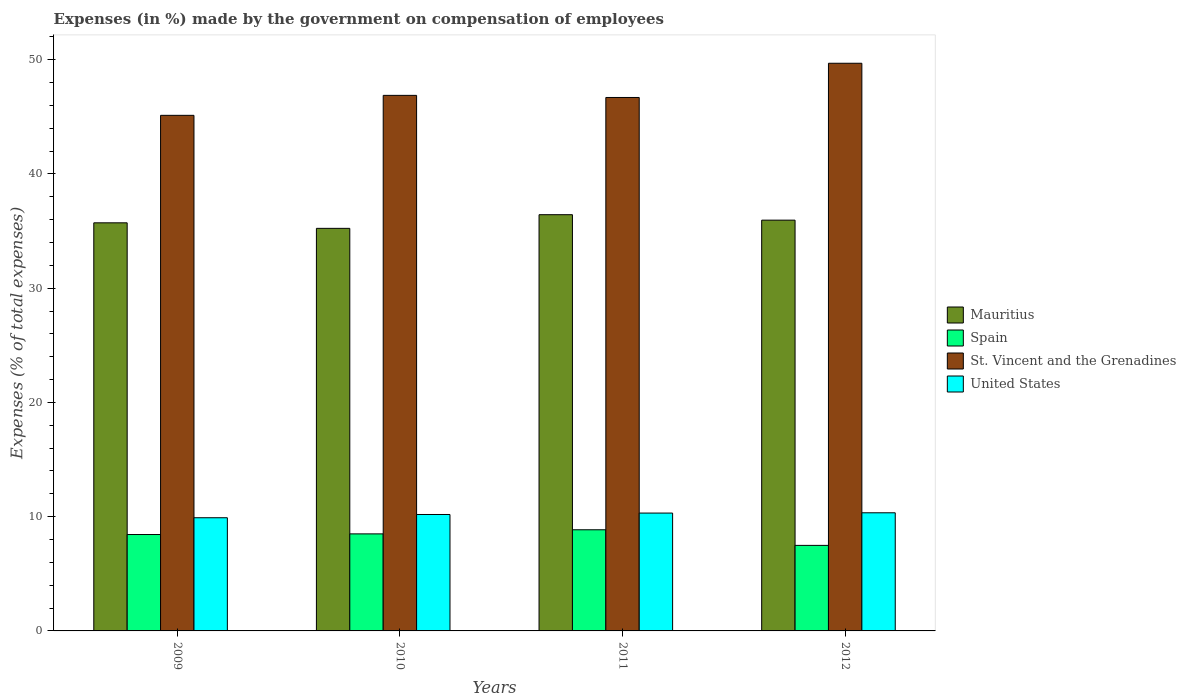Are the number of bars on each tick of the X-axis equal?
Your answer should be very brief. Yes. How many bars are there on the 2nd tick from the left?
Offer a very short reply. 4. How many bars are there on the 2nd tick from the right?
Your response must be concise. 4. What is the label of the 2nd group of bars from the left?
Keep it short and to the point. 2010. What is the percentage of expenses made by the government on compensation of employees in United States in 2011?
Make the answer very short. 10.31. Across all years, what is the maximum percentage of expenses made by the government on compensation of employees in United States?
Keep it short and to the point. 10.34. Across all years, what is the minimum percentage of expenses made by the government on compensation of employees in Spain?
Provide a succinct answer. 7.49. In which year was the percentage of expenses made by the government on compensation of employees in Mauritius maximum?
Your response must be concise. 2011. What is the total percentage of expenses made by the government on compensation of employees in St. Vincent and the Grenadines in the graph?
Your answer should be compact. 188.37. What is the difference between the percentage of expenses made by the government on compensation of employees in United States in 2011 and that in 2012?
Offer a terse response. -0.02. What is the difference between the percentage of expenses made by the government on compensation of employees in St. Vincent and the Grenadines in 2011 and the percentage of expenses made by the government on compensation of employees in Spain in 2010?
Make the answer very short. 38.2. What is the average percentage of expenses made by the government on compensation of employees in Spain per year?
Your answer should be very brief. 8.32. In the year 2011, what is the difference between the percentage of expenses made by the government on compensation of employees in Spain and percentage of expenses made by the government on compensation of employees in United States?
Offer a terse response. -1.46. In how many years, is the percentage of expenses made by the government on compensation of employees in St. Vincent and the Grenadines greater than 44 %?
Your response must be concise. 4. What is the ratio of the percentage of expenses made by the government on compensation of employees in Spain in 2009 to that in 2010?
Keep it short and to the point. 0.99. Is the percentage of expenses made by the government on compensation of employees in United States in 2010 less than that in 2012?
Offer a terse response. Yes. Is the difference between the percentage of expenses made by the government on compensation of employees in Spain in 2010 and 2011 greater than the difference between the percentage of expenses made by the government on compensation of employees in United States in 2010 and 2011?
Your response must be concise. No. What is the difference between the highest and the second highest percentage of expenses made by the government on compensation of employees in Mauritius?
Offer a terse response. 0.48. What is the difference between the highest and the lowest percentage of expenses made by the government on compensation of employees in Spain?
Your answer should be very brief. 1.37. In how many years, is the percentage of expenses made by the government on compensation of employees in United States greater than the average percentage of expenses made by the government on compensation of employees in United States taken over all years?
Ensure brevity in your answer.  3. Is the sum of the percentage of expenses made by the government on compensation of employees in United States in 2009 and 2010 greater than the maximum percentage of expenses made by the government on compensation of employees in Spain across all years?
Give a very brief answer. Yes. What does the 1st bar from the left in 2009 represents?
Provide a short and direct response. Mauritius. What does the 4th bar from the right in 2012 represents?
Keep it short and to the point. Mauritius. Are all the bars in the graph horizontal?
Provide a succinct answer. No. How many years are there in the graph?
Keep it short and to the point. 4. What is the difference between two consecutive major ticks on the Y-axis?
Provide a succinct answer. 10. Are the values on the major ticks of Y-axis written in scientific E-notation?
Offer a terse response. No. Does the graph contain grids?
Make the answer very short. No. How are the legend labels stacked?
Your answer should be very brief. Vertical. What is the title of the graph?
Your answer should be very brief. Expenses (in %) made by the government on compensation of employees. Does "Italy" appear as one of the legend labels in the graph?
Your answer should be compact. No. What is the label or title of the Y-axis?
Ensure brevity in your answer.  Expenses (% of total expenses). What is the Expenses (% of total expenses) in Mauritius in 2009?
Ensure brevity in your answer.  35.72. What is the Expenses (% of total expenses) in Spain in 2009?
Offer a very short reply. 8.44. What is the Expenses (% of total expenses) of St. Vincent and the Grenadines in 2009?
Keep it short and to the point. 45.13. What is the Expenses (% of total expenses) of United States in 2009?
Your answer should be very brief. 9.91. What is the Expenses (% of total expenses) in Mauritius in 2010?
Ensure brevity in your answer.  35.23. What is the Expenses (% of total expenses) of Spain in 2010?
Ensure brevity in your answer.  8.49. What is the Expenses (% of total expenses) of St. Vincent and the Grenadines in 2010?
Provide a short and direct response. 46.87. What is the Expenses (% of total expenses) in United States in 2010?
Your response must be concise. 10.19. What is the Expenses (% of total expenses) in Mauritius in 2011?
Provide a short and direct response. 36.43. What is the Expenses (% of total expenses) in Spain in 2011?
Your answer should be compact. 8.85. What is the Expenses (% of total expenses) in St. Vincent and the Grenadines in 2011?
Make the answer very short. 46.69. What is the Expenses (% of total expenses) in United States in 2011?
Make the answer very short. 10.31. What is the Expenses (% of total expenses) in Mauritius in 2012?
Make the answer very short. 35.95. What is the Expenses (% of total expenses) of Spain in 2012?
Give a very brief answer. 7.49. What is the Expenses (% of total expenses) in St. Vincent and the Grenadines in 2012?
Your answer should be compact. 49.68. What is the Expenses (% of total expenses) in United States in 2012?
Offer a very short reply. 10.34. Across all years, what is the maximum Expenses (% of total expenses) in Mauritius?
Offer a very short reply. 36.43. Across all years, what is the maximum Expenses (% of total expenses) of Spain?
Offer a very short reply. 8.85. Across all years, what is the maximum Expenses (% of total expenses) in St. Vincent and the Grenadines?
Make the answer very short. 49.68. Across all years, what is the maximum Expenses (% of total expenses) of United States?
Your answer should be very brief. 10.34. Across all years, what is the minimum Expenses (% of total expenses) of Mauritius?
Provide a short and direct response. 35.23. Across all years, what is the minimum Expenses (% of total expenses) of Spain?
Offer a terse response. 7.49. Across all years, what is the minimum Expenses (% of total expenses) in St. Vincent and the Grenadines?
Your response must be concise. 45.13. Across all years, what is the minimum Expenses (% of total expenses) in United States?
Your answer should be very brief. 9.91. What is the total Expenses (% of total expenses) of Mauritius in the graph?
Offer a terse response. 143.33. What is the total Expenses (% of total expenses) of Spain in the graph?
Give a very brief answer. 33.27. What is the total Expenses (% of total expenses) in St. Vincent and the Grenadines in the graph?
Make the answer very short. 188.37. What is the total Expenses (% of total expenses) in United States in the graph?
Ensure brevity in your answer.  40.75. What is the difference between the Expenses (% of total expenses) in Mauritius in 2009 and that in 2010?
Provide a succinct answer. 0.49. What is the difference between the Expenses (% of total expenses) of Spain in 2009 and that in 2010?
Offer a very short reply. -0.06. What is the difference between the Expenses (% of total expenses) in St. Vincent and the Grenadines in 2009 and that in 2010?
Ensure brevity in your answer.  -1.75. What is the difference between the Expenses (% of total expenses) in United States in 2009 and that in 2010?
Your answer should be compact. -0.28. What is the difference between the Expenses (% of total expenses) of Mauritius in 2009 and that in 2011?
Make the answer very short. -0.71. What is the difference between the Expenses (% of total expenses) in Spain in 2009 and that in 2011?
Offer a terse response. -0.42. What is the difference between the Expenses (% of total expenses) of St. Vincent and the Grenadines in 2009 and that in 2011?
Offer a terse response. -1.56. What is the difference between the Expenses (% of total expenses) in United States in 2009 and that in 2011?
Make the answer very short. -0.41. What is the difference between the Expenses (% of total expenses) in Mauritius in 2009 and that in 2012?
Your answer should be very brief. -0.23. What is the difference between the Expenses (% of total expenses) in Spain in 2009 and that in 2012?
Give a very brief answer. 0.95. What is the difference between the Expenses (% of total expenses) of St. Vincent and the Grenadines in 2009 and that in 2012?
Provide a short and direct response. -4.56. What is the difference between the Expenses (% of total expenses) in United States in 2009 and that in 2012?
Your response must be concise. -0.43. What is the difference between the Expenses (% of total expenses) of Mauritius in 2010 and that in 2011?
Offer a very short reply. -1.2. What is the difference between the Expenses (% of total expenses) in Spain in 2010 and that in 2011?
Provide a succinct answer. -0.36. What is the difference between the Expenses (% of total expenses) of St. Vincent and the Grenadines in 2010 and that in 2011?
Offer a very short reply. 0.18. What is the difference between the Expenses (% of total expenses) in United States in 2010 and that in 2011?
Offer a terse response. -0.12. What is the difference between the Expenses (% of total expenses) of Mauritius in 2010 and that in 2012?
Your answer should be very brief. -0.72. What is the difference between the Expenses (% of total expenses) in Spain in 2010 and that in 2012?
Provide a short and direct response. 1.01. What is the difference between the Expenses (% of total expenses) in St. Vincent and the Grenadines in 2010 and that in 2012?
Ensure brevity in your answer.  -2.81. What is the difference between the Expenses (% of total expenses) in United States in 2010 and that in 2012?
Give a very brief answer. -0.15. What is the difference between the Expenses (% of total expenses) in Mauritius in 2011 and that in 2012?
Your answer should be compact. 0.48. What is the difference between the Expenses (% of total expenses) of Spain in 2011 and that in 2012?
Your response must be concise. 1.37. What is the difference between the Expenses (% of total expenses) of St. Vincent and the Grenadines in 2011 and that in 2012?
Give a very brief answer. -2.99. What is the difference between the Expenses (% of total expenses) of United States in 2011 and that in 2012?
Keep it short and to the point. -0.02. What is the difference between the Expenses (% of total expenses) of Mauritius in 2009 and the Expenses (% of total expenses) of Spain in 2010?
Provide a succinct answer. 27.23. What is the difference between the Expenses (% of total expenses) in Mauritius in 2009 and the Expenses (% of total expenses) in St. Vincent and the Grenadines in 2010?
Offer a terse response. -11.15. What is the difference between the Expenses (% of total expenses) in Mauritius in 2009 and the Expenses (% of total expenses) in United States in 2010?
Keep it short and to the point. 25.53. What is the difference between the Expenses (% of total expenses) in Spain in 2009 and the Expenses (% of total expenses) in St. Vincent and the Grenadines in 2010?
Your answer should be very brief. -38.44. What is the difference between the Expenses (% of total expenses) in Spain in 2009 and the Expenses (% of total expenses) in United States in 2010?
Offer a terse response. -1.75. What is the difference between the Expenses (% of total expenses) in St. Vincent and the Grenadines in 2009 and the Expenses (% of total expenses) in United States in 2010?
Your response must be concise. 34.94. What is the difference between the Expenses (% of total expenses) in Mauritius in 2009 and the Expenses (% of total expenses) in Spain in 2011?
Offer a very short reply. 26.87. What is the difference between the Expenses (% of total expenses) in Mauritius in 2009 and the Expenses (% of total expenses) in St. Vincent and the Grenadines in 2011?
Your answer should be compact. -10.97. What is the difference between the Expenses (% of total expenses) in Mauritius in 2009 and the Expenses (% of total expenses) in United States in 2011?
Your answer should be compact. 25.4. What is the difference between the Expenses (% of total expenses) of Spain in 2009 and the Expenses (% of total expenses) of St. Vincent and the Grenadines in 2011?
Provide a short and direct response. -38.25. What is the difference between the Expenses (% of total expenses) in Spain in 2009 and the Expenses (% of total expenses) in United States in 2011?
Your answer should be compact. -1.88. What is the difference between the Expenses (% of total expenses) of St. Vincent and the Grenadines in 2009 and the Expenses (% of total expenses) of United States in 2011?
Ensure brevity in your answer.  34.81. What is the difference between the Expenses (% of total expenses) in Mauritius in 2009 and the Expenses (% of total expenses) in Spain in 2012?
Your answer should be very brief. 28.23. What is the difference between the Expenses (% of total expenses) of Mauritius in 2009 and the Expenses (% of total expenses) of St. Vincent and the Grenadines in 2012?
Make the answer very short. -13.96. What is the difference between the Expenses (% of total expenses) in Mauritius in 2009 and the Expenses (% of total expenses) in United States in 2012?
Ensure brevity in your answer.  25.38. What is the difference between the Expenses (% of total expenses) of Spain in 2009 and the Expenses (% of total expenses) of St. Vincent and the Grenadines in 2012?
Give a very brief answer. -41.25. What is the difference between the Expenses (% of total expenses) of Spain in 2009 and the Expenses (% of total expenses) of United States in 2012?
Your response must be concise. -1.9. What is the difference between the Expenses (% of total expenses) in St. Vincent and the Grenadines in 2009 and the Expenses (% of total expenses) in United States in 2012?
Provide a short and direct response. 34.79. What is the difference between the Expenses (% of total expenses) of Mauritius in 2010 and the Expenses (% of total expenses) of Spain in 2011?
Provide a short and direct response. 26.38. What is the difference between the Expenses (% of total expenses) in Mauritius in 2010 and the Expenses (% of total expenses) in St. Vincent and the Grenadines in 2011?
Provide a succinct answer. -11.45. What is the difference between the Expenses (% of total expenses) of Mauritius in 2010 and the Expenses (% of total expenses) of United States in 2011?
Keep it short and to the point. 24.92. What is the difference between the Expenses (% of total expenses) in Spain in 2010 and the Expenses (% of total expenses) in St. Vincent and the Grenadines in 2011?
Your answer should be very brief. -38.2. What is the difference between the Expenses (% of total expenses) of Spain in 2010 and the Expenses (% of total expenses) of United States in 2011?
Keep it short and to the point. -1.82. What is the difference between the Expenses (% of total expenses) of St. Vincent and the Grenadines in 2010 and the Expenses (% of total expenses) of United States in 2011?
Offer a very short reply. 36.56. What is the difference between the Expenses (% of total expenses) in Mauritius in 2010 and the Expenses (% of total expenses) in Spain in 2012?
Provide a short and direct response. 27.75. What is the difference between the Expenses (% of total expenses) of Mauritius in 2010 and the Expenses (% of total expenses) of St. Vincent and the Grenadines in 2012?
Give a very brief answer. -14.45. What is the difference between the Expenses (% of total expenses) of Mauritius in 2010 and the Expenses (% of total expenses) of United States in 2012?
Provide a succinct answer. 24.89. What is the difference between the Expenses (% of total expenses) of Spain in 2010 and the Expenses (% of total expenses) of St. Vincent and the Grenadines in 2012?
Ensure brevity in your answer.  -41.19. What is the difference between the Expenses (% of total expenses) of Spain in 2010 and the Expenses (% of total expenses) of United States in 2012?
Your answer should be compact. -1.85. What is the difference between the Expenses (% of total expenses) of St. Vincent and the Grenadines in 2010 and the Expenses (% of total expenses) of United States in 2012?
Give a very brief answer. 36.53. What is the difference between the Expenses (% of total expenses) of Mauritius in 2011 and the Expenses (% of total expenses) of Spain in 2012?
Offer a very short reply. 28.94. What is the difference between the Expenses (% of total expenses) in Mauritius in 2011 and the Expenses (% of total expenses) in St. Vincent and the Grenadines in 2012?
Give a very brief answer. -13.25. What is the difference between the Expenses (% of total expenses) in Mauritius in 2011 and the Expenses (% of total expenses) in United States in 2012?
Your response must be concise. 26.09. What is the difference between the Expenses (% of total expenses) of Spain in 2011 and the Expenses (% of total expenses) of St. Vincent and the Grenadines in 2012?
Make the answer very short. -40.83. What is the difference between the Expenses (% of total expenses) in Spain in 2011 and the Expenses (% of total expenses) in United States in 2012?
Give a very brief answer. -1.49. What is the difference between the Expenses (% of total expenses) in St. Vincent and the Grenadines in 2011 and the Expenses (% of total expenses) in United States in 2012?
Offer a terse response. 36.35. What is the average Expenses (% of total expenses) in Mauritius per year?
Ensure brevity in your answer.  35.83. What is the average Expenses (% of total expenses) of Spain per year?
Your answer should be compact. 8.32. What is the average Expenses (% of total expenses) of St. Vincent and the Grenadines per year?
Your answer should be compact. 47.09. What is the average Expenses (% of total expenses) of United States per year?
Your response must be concise. 10.19. In the year 2009, what is the difference between the Expenses (% of total expenses) in Mauritius and Expenses (% of total expenses) in Spain?
Offer a terse response. 27.28. In the year 2009, what is the difference between the Expenses (% of total expenses) of Mauritius and Expenses (% of total expenses) of St. Vincent and the Grenadines?
Provide a succinct answer. -9.41. In the year 2009, what is the difference between the Expenses (% of total expenses) of Mauritius and Expenses (% of total expenses) of United States?
Offer a very short reply. 25.81. In the year 2009, what is the difference between the Expenses (% of total expenses) of Spain and Expenses (% of total expenses) of St. Vincent and the Grenadines?
Provide a succinct answer. -36.69. In the year 2009, what is the difference between the Expenses (% of total expenses) of Spain and Expenses (% of total expenses) of United States?
Give a very brief answer. -1.47. In the year 2009, what is the difference between the Expenses (% of total expenses) of St. Vincent and the Grenadines and Expenses (% of total expenses) of United States?
Your answer should be very brief. 35.22. In the year 2010, what is the difference between the Expenses (% of total expenses) of Mauritius and Expenses (% of total expenses) of Spain?
Your answer should be compact. 26.74. In the year 2010, what is the difference between the Expenses (% of total expenses) in Mauritius and Expenses (% of total expenses) in St. Vincent and the Grenadines?
Offer a very short reply. -11.64. In the year 2010, what is the difference between the Expenses (% of total expenses) of Mauritius and Expenses (% of total expenses) of United States?
Give a very brief answer. 25.04. In the year 2010, what is the difference between the Expenses (% of total expenses) of Spain and Expenses (% of total expenses) of St. Vincent and the Grenadines?
Your response must be concise. -38.38. In the year 2010, what is the difference between the Expenses (% of total expenses) of Spain and Expenses (% of total expenses) of United States?
Offer a terse response. -1.7. In the year 2010, what is the difference between the Expenses (% of total expenses) of St. Vincent and the Grenadines and Expenses (% of total expenses) of United States?
Your answer should be very brief. 36.68. In the year 2011, what is the difference between the Expenses (% of total expenses) in Mauritius and Expenses (% of total expenses) in Spain?
Make the answer very short. 27.58. In the year 2011, what is the difference between the Expenses (% of total expenses) of Mauritius and Expenses (% of total expenses) of St. Vincent and the Grenadines?
Your answer should be very brief. -10.26. In the year 2011, what is the difference between the Expenses (% of total expenses) of Mauritius and Expenses (% of total expenses) of United States?
Your answer should be very brief. 26.11. In the year 2011, what is the difference between the Expenses (% of total expenses) of Spain and Expenses (% of total expenses) of St. Vincent and the Grenadines?
Provide a succinct answer. -37.84. In the year 2011, what is the difference between the Expenses (% of total expenses) of Spain and Expenses (% of total expenses) of United States?
Your response must be concise. -1.46. In the year 2011, what is the difference between the Expenses (% of total expenses) in St. Vincent and the Grenadines and Expenses (% of total expenses) in United States?
Provide a short and direct response. 36.37. In the year 2012, what is the difference between the Expenses (% of total expenses) of Mauritius and Expenses (% of total expenses) of Spain?
Provide a short and direct response. 28.47. In the year 2012, what is the difference between the Expenses (% of total expenses) in Mauritius and Expenses (% of total expenses) in St. Vincent and the Grenadines?
Offer a very short reply. -13.73. In the year 2012, what is the difference between the Expenses (% of total expenses) in Mauritius and Expenses (% of total expenses) in United States?
Offer a terse response. 25.61. In the year 2012, what is the difference between the Expenses (% of total expenses) in Spain and Expenses (% of total expenses) in St. Vincent and the Grenadines?
Offer a terse response. -42.2. In the year 2012, what is the difference between the Expenses (% of total expenses) in Spain and Expenses (% of total expenses) in United States?
Make the answer very short. -2.85. In the year 2012, what is the difference between the Expenses (% of total expenses) of St. Vincent and the Grenadines and Expenses (% of total expenses) of United States?
Provide a succinct answer. 39.34. What is the ratio of the Expenses (% of total expenses) of Mauritius in 2009 to that in 2010?
Give a very brief answer. 1.01. What is the ratio of the Expenses (% of total expenses) in Spain in 2009 to that in 2010?
Offer a very short reply. 0.99. What is the ratio of the Expenses (% of total expenses) of St. Vincent and the Grenadines in 2009 to that in 2010?
Ensure brevity in your answer.  0.96. What is the ratio of the Expenses (% of total expenses) of United States in 2009 to that in 2010?
Your answer should be very brief. 0.97. What is the ratio of the Expenses (% of total expenses) of Mauritius in 2009 to that in 2011?
Provide a short and direct response. 0.98. What is the ratio of the Expenses (% of total expenses) of Spain in 2009 to that in 2011?
Your answer should be very brief. 0.95. What is the ratio of the Expenses (% of total expenses) of St. Vincent and the Grenadines in 2009 to that in 2011?
Give a very brief answer. 0.97. What is the ratio of the Expenses (% of total expenses) of United States in 2009 to that in 2011?
Provide a succinct answer. 0.96. What is the ratio of the Expenses (% of total expenses) of Spain in 2009 to that in 2012?
Your answer should be compact. 1.13. What is the ratio of the Expenses (% of total expenses) of St. Vincent and the Grenadines in 2009 to that in 2012?
Give a very brief answer. 0.91. What is the ratio of the Expenses (% of total expenses) of United States in 2009 to that in 2012?
Provide a succinct answer. 0.96. What is the ratio of the Expenses (% of total expenses) of Mauritius in 2010 to that in 2011?
Give a very brief answer. 0.97. What is the ratio of the Expenses (% of total expenses) in Spain in 2010 to that in 2011?
Offer a very short reply. 0.96. What is the ratio of the Expenses (% of total expenses) in St. Vincent and the Grenadines in 2010 to that in 2011?
Your answer should be very brief. 1. What is the ratio of the Expenses (% of total expenses) in United States in 2010 to that in 2011?
Make the answer very short. 0.99. What is the ratio of the Expenses (% of total expenses) in Mauritius in 2010 to that in 2012?
Your response must be concise. 0.98. What is the ratio of the Expenses (% of total expenses) in Spain in 2010 to that in 2012?
Offer a terse response. 1.13. What is the ratio of the Expenses (% of total expenses) in St. Vincent and the Grenadines in 2010 to that in 2012?
Make the answer very short. 0.94. What is the ratio of the Expenses (% of total expenses) of United States in 2010 to that in 2012?
Keep it short and to the point. 0.99. What is the ratio of the Expenses (% of total expenses) in Mauritius in 2011 to that in 2012?
Provide a succinct answer. 1.01. What is the ratio of the Expenses (% of total expenses) in Spain in 2011 to that in 2012?
Your answer should be very brief. 1.18. What is the ratio of the Expenses (% of total expenses) of St. Vincent and the Grenadines in 2011 to that in 2012?
Ensure brevity in your answer.  0.94. What is the ratio of the Expenses (% of total expenses) in United States in 2011 to that in 2012?
Offer a very short reply. 1. What is the difference between the highest and the second highest Expenses (% of total expenses) of Mauritius?
Your answer should be compact. 0.48. What is the difference between the highest and the second highest Expenses (% of total expenses) of Spain?
Your answer should be very brief. 0.36. What is the difference between the highest and the second highest Expenses (% of total expenses) in St. Vincent and the Grenadines?
Your response must be concise. 2.81. What is the difference between the highest and the second highest Expenses (% of total expenses) of United States?
Offer a very short reply. 0.02. What is the difference between the highest and the lowest Expenses (% of total expenses) of Mauritius?
Ensure brevity in your answer.  1.2. What is the difference between the highest and the lowest Expenses (% of total expenses) of Spain?
Your answer should be very brief. 1.37. What is the difference between the highest and the lowest Expenses (% of total expenses) in St. Vincent and the Grenadines?
Offer a very short reply. 4.56. What is the difference between the highest and the lowest Expenses (% of total expenses) in United States?
Your answer should be very brief. 0.43. 